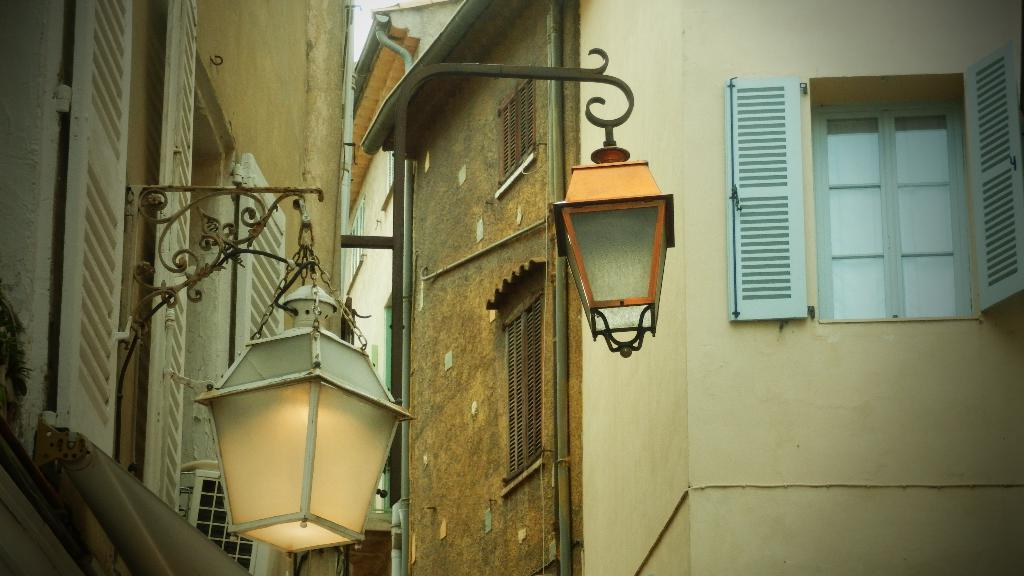How many lamps are in the image? There are two lamps in the image. How are the lamps suspended in the image? The lamps are hanged on metal rods. What is the metal rods attached to in the image? The metal rods are attached to a wall. What can be seen through the windows on the wall? There are buildings visible in the background of the image? What type of haircut is the wall getting in the image? There is no haircut present in the image, as the wall is a part of a building and not a living being. 